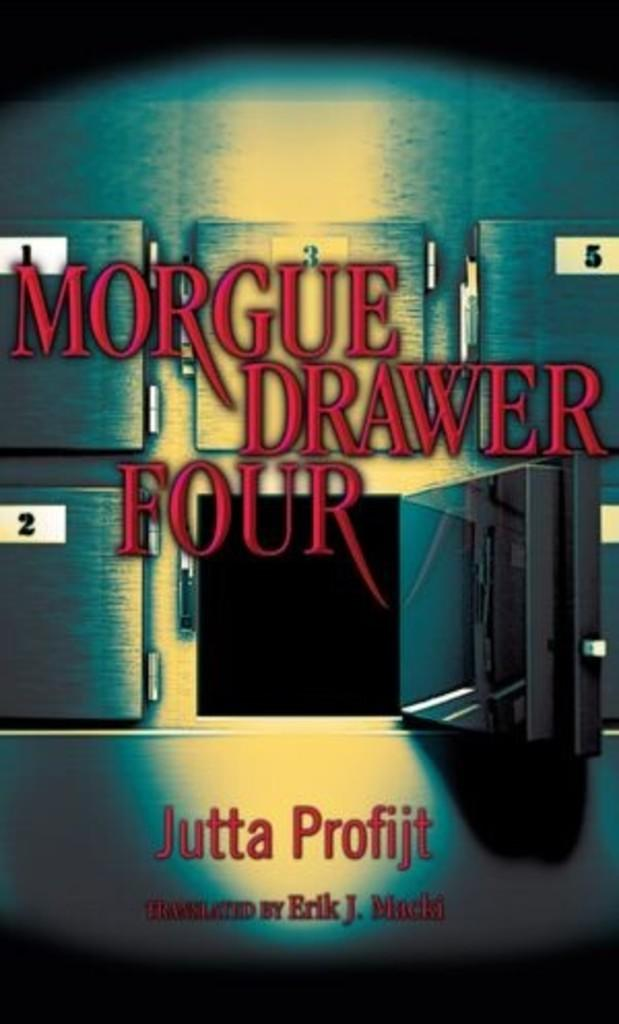<image>
Summarize the visual content of the image. The picture shows a morgue in particular the opened drawer four. 